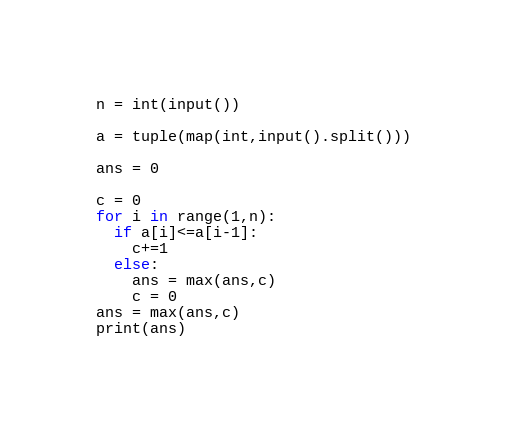<code> <loc_0><loc_0><loc_500><loc_500><_Python_>n = int(input())

a = tuple(map(int,input().split()))

ans = 0

c = 0
for i in range(1,n):
  if a[i]<=a[i-1]:
    c+=1
  else:
    ans = max(ans,c)
    c = 0
ans = max(ans,c) 
print(ans)
</code> 